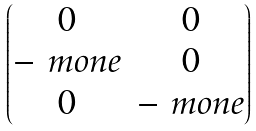Convert formula to latex. <formula><loc_0><loc_0><loc_500><loc_500>\begin{pmatrix} 0 & 0 \\ - \ m o n e & 0 \\ 0 & - \ m o n e \\ \end{pmatrix}</formula> 